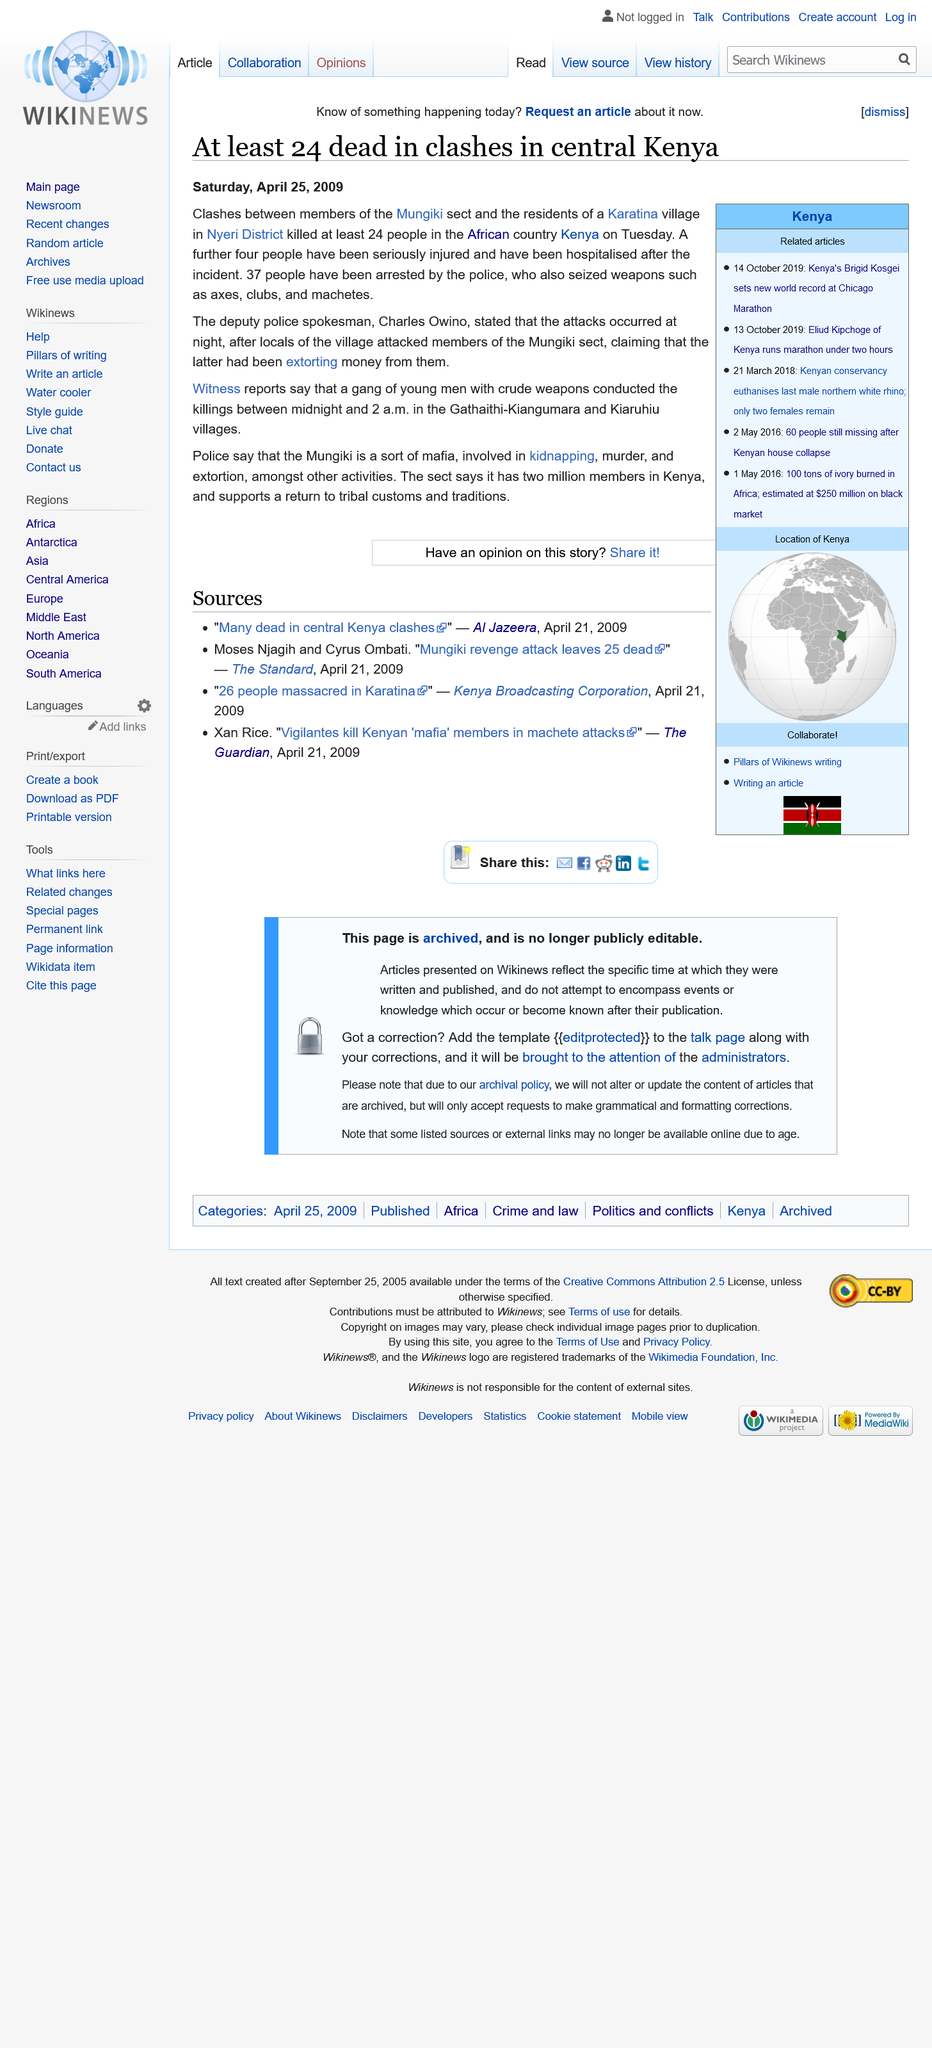Draw attention to some important aspects in this diagram. It is reported that there are approximately two million members of the Mungiki in Kenya. The clashes occurred in the Karatina villages of Gathaithi-Kiangumara and Kiaruhiu in the Nyeri District of Kenya. Thirty-seven arrests were made. 